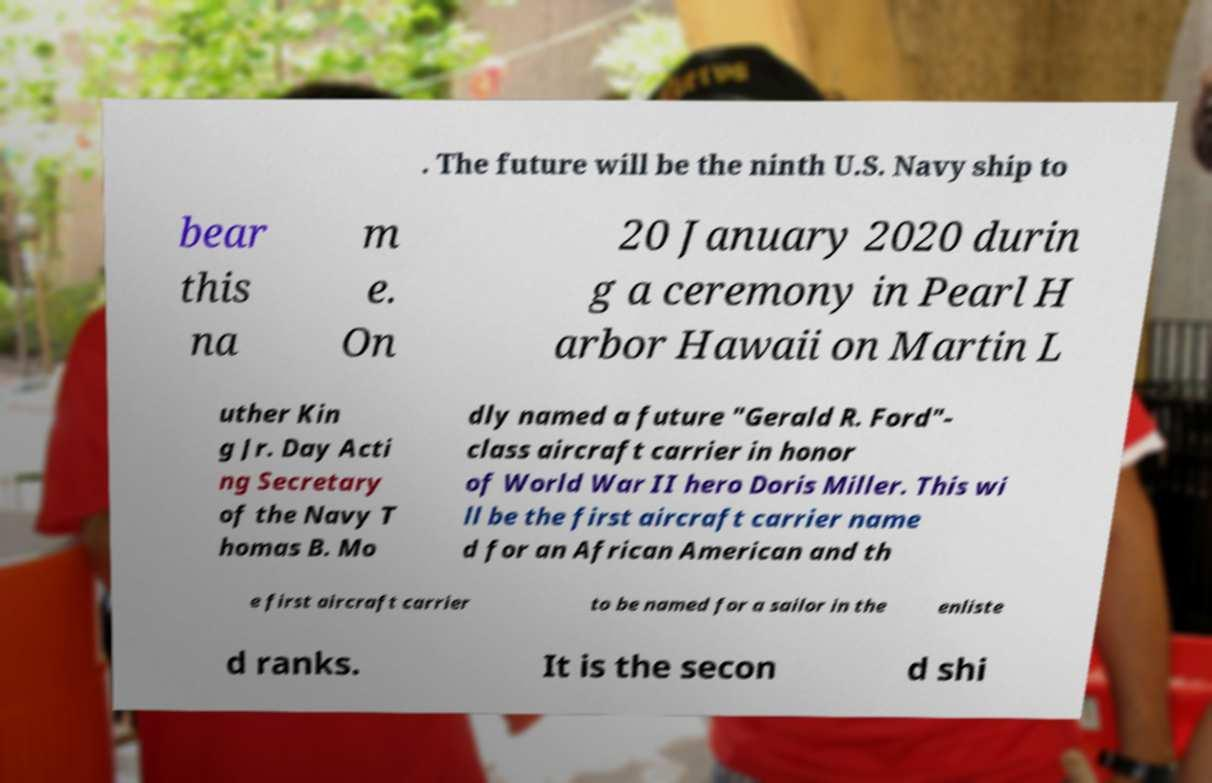Can you accurately transcribe the text from the provided image for me? . The future will be the ninth U.S. Navy ship to bear this na m e. On 20 January 2020 durin g a ceremony in Pearl H arbor Hawaii on Martin L uther Kin g Jr. Day Acti ng Secretary of the Navy T homas B. Mo dly named a future "Gerald R. Ford"- class aircraft carrier in honor of World War II hero Doris Miller. This wi ll be the first aircraft carrier name d for an African American and th e first aircraft carrier to be named for a sailor in the enliste d ranks. It is the secon d shi 